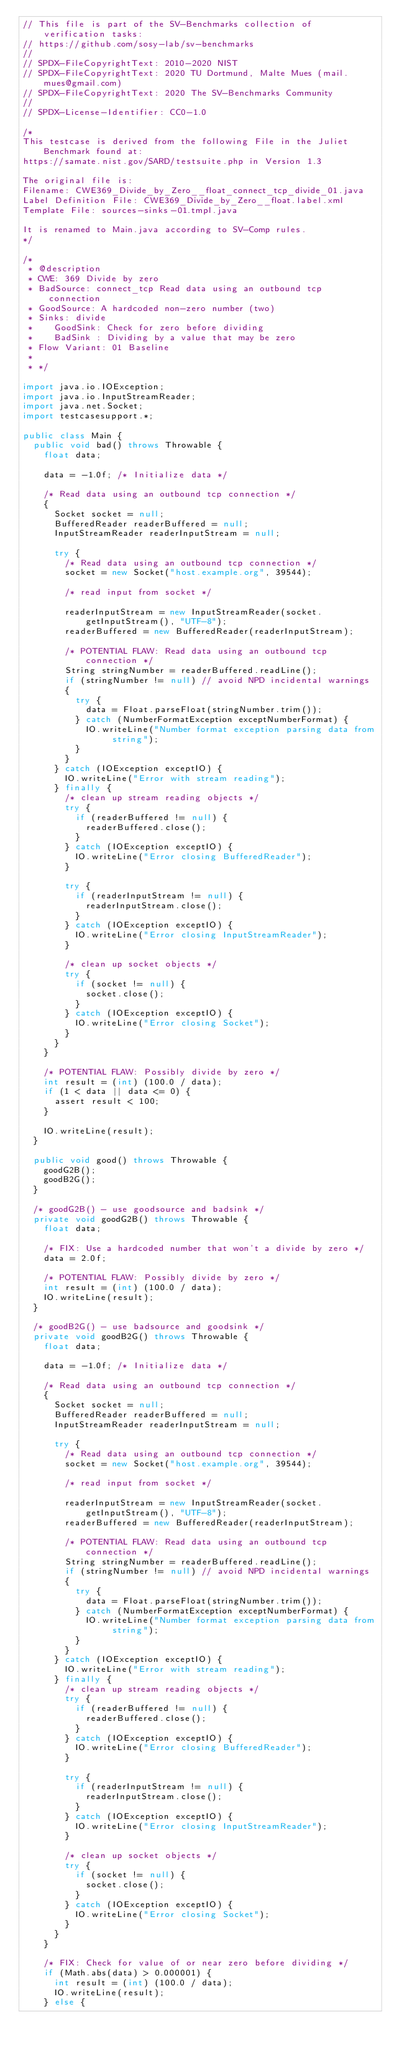<code> <loc_0><loc_0><loc_500><loc_500><_Java_>// This file is part of the SV-Benchmarks collection of verification tasks:
// https://github.com/sosy-lab/sv-benchmarks
//
// SPDX-FileCopyrightText: 2010-2020 NIST
// SPDX-FileCopyrightText: 2020 TU Dortmund, Malte Mues (mail.mues@gmail.com)
// SPDX-FileCopyrightText: 2020 The SV-Benchmarks Community
//
// SPDX-License-Identifier: CC0-1.0

/*
This testcase is derived from the following File in the Juliet Benchmark found at:
https://samate.nist.gov/SARD/testsuite.php in Version 1.3

The original file is:
Filename: CWE369_Divide_by_Zero__float_connect_tcp_divide_01.java
Label Definition File: CWE369_Divide_by_Zero__float.label.xml
Template File: sources-sinks-01.tmpl.java

It is renamed to Main.java according to SV-Comp rules.
*/

/*
 * @description
 * CWE: 369 Divide by zero
 * BadSource: connect_tcp Read data using an outbound tcp connection
 * GoodSource: A hardcoded non-zero number (two)
 * Sinks: divide
 *    GoodSink: Check for zero before dividing
 *    BadSink : Dividing by a value that may be zero
 * Flow Variant: 01 Baseline
 *
 * */

import java.io.IOException;
import java.io.InputStreamReader;
import java.net.Socket;
import testcasesupport.*;

public class Main {
  public void bad() throws Throwable {
    float data;

    data = -1.0f; /* Initialize data */

    /* Read data using an outbound tcp connection */
    {
      Socket socket = null;
      BufferedReader readerBuffered = null;
      InputStreamReader readerInputStream = null;

      try {
        /* Read data using an outbound tcp connection */
        socket = new Socket("host.example.org", 39544);

        /* read input from socket */

        readerInputStream = new InputStreamReader(socket.getInputStream(), "UTF-8");
        readerBuffered = new BufferedReader(readerInputStream);

        /* POTENTIAL FLAW: Read data using an outbound tcp connection */
        String stringNumber = readerBuffered.readLine();
        if (stringNumber != null) // avoid NPD incidental warnings
        {
          try {
            data = Float.parseFloat(stringNumber.trim());
          } catch (NumberFormatException exceptNumberFormat) {
            IO.writeLine("Number format exception parsing data from string");
          }
        }
      } catch (IOException exceptIO) {
        IO.writeLine("Error with stream reading");
      } finally {
        /* clean up stream reading objects */
        try {
          if (readerBuffered != null) {
            readerBuffered.close();
          }
        } catch (IOException exceptIO) {
          IO.writeLine("Error closing BufferedReader");
        }

        try {
          if (readerInputStream != null) {
            readerInputStream.close();
          }
        } catch (IOException exceptIO) {
          IO.writeLine("Error closing InputStreamReader");
        }

        /* clean up socket objects */
        try {
          if (socket != null) {
            socket.close();
          }
        } catch (IOException exceptIO) {
          IO.writeLine("Error closing Socket");
        }
      }
    }

    /* POTENTIAL FLAW: Possibly divide by zero */
    int result = (int) (100.0 / data);
    if (1 < data || data <= 0) {
      assert result < 100;
    }

    IO.writeLine(result);
  }

  public void good() throws Throwable {
    goodG2B();
    goodB2G();
  }

  /* goodG2B() - use goodsource and badsink */
  private void goodG2B() throws Throwable {
    float data;

    /* FIX: Use a hardcoded number that won't a divide by zero */
    data = 2.0f;

    /* POTENTIAL FLAW: Possibly divide by zero */
    int result = (int) (100.0 / data);
    IO.writeLine(result);
  }

  /* goodB2G() - use badsource and goodsink */
  private void goodB2G() throws Throwable {
    float data;

    data = -1.0f; /* Initialize data */

    /* Read data using an outbound tcp connection */
    {
      Socket socket = null;
      BufferedReader readerBuffered = null;
      InputStreamReader readerInputStream = null;

      try {
        /* Read data using an outbound tcp connection */
        socket = new Socket("host.example.org", 39544);

        /* read input from socket */

        readerInputStream = new InputStreamReader(socket.getInputStream(), "UTF-8");
        readerBuffered = new BufferedReader(readerInputStream);

        /* POTENTIAL FLAW: Read data using an outbound tcp connection */
        String stringNumber = readerBuffered.readLine();
        if (stringNumber != null) // avoid NPD incidental warnings
        {
          try {
            data = Float.parseFloat(stringNumber.trim());
          } catch (NumberFormatException exceptNumberFormat) {
            IO.writeLine("Number format exception parsing data from string");
          }
        }
      } catch (IOException exceptIO) {
        IO.writeLine("Error with stream reading");
      } finally {
        /* clean up stream reading objects */
        try {
          if (readerBuffered != null) {
            readerBuffered.close();
          }
        } catch (IOException exceptIO) {
          IO.writeLine("Error closing BufferedReader");
        }

        try {
          if (readerInputStream != null) {
            readerInputStream.close();
          }
        } catch (IOException exceptIO) {
          IO.writeLine("Error closing InputStreamReader");
        }

        /* clean up socket objects */
        try {
          if (socket != null) {
            socket.close();
          }
        } catch (IOException exceptIO) {
          IO.writeLine("Error closing Socket");
        }
      }
    }

    /* FIX: Check for value of or near zero before dividing */
    if (Math.abs(data) > 0.000001) {
      int result = (int) (100.0 / data);
      IO.writeLine(result);
    } else {</code> 